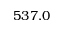Convert formula to latex. <formula><loc_0><loc_0><loc_500><loc_500>5 3 7 . 0</formula> 